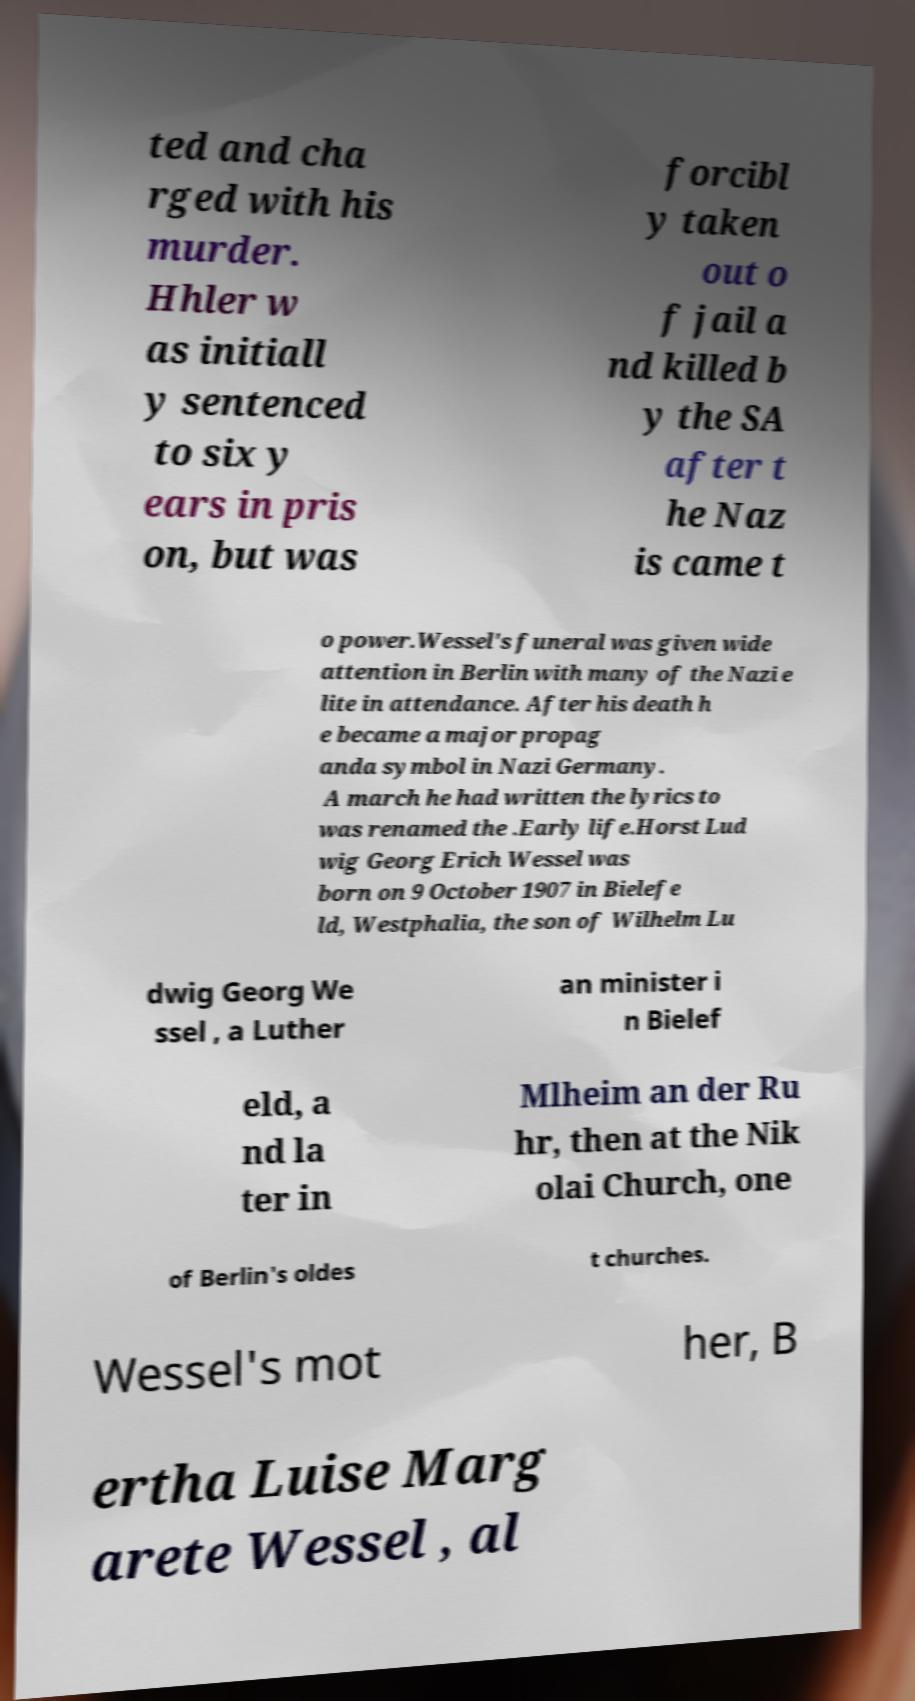For documentation purposes, I need the text within this image transcribed. Could you provide that? ted and cha rged with his murder. Hhler w as initiall y sentenced to six y ears in pris on, but was forcibl y taken out o f jail a nd killed b y the SA after t he Naz is came t o power.Wessel's funeral was given wide attention in Berlin with many of the Nazi e lite in attendance. After his death h e became a major propag anda symbol in Nazi Germany. A march he had written the lyrics to was renamed the .Early life.Horst Lud wig Georg Erich Wessel was born on 9 October 1907 in Bielefe ld, Westphalia, the son of Wilhelm Lu dwig Georg We ssel , a Luther an minister i n Bielef eld, a nd la ter in Mlheim an der Ru hr, then at the Nik olai Church, one of Berlin's oldes t churches. Wessel's mot her, B ertha Luise Marg arete Wessel , al 